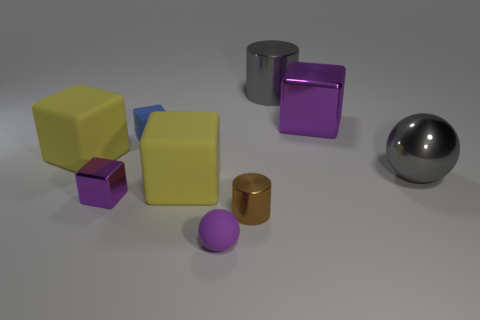The tiny cylinder that is on the right side of the small matte thing in front of the big thing that is on the left side of the small matte block is made of what material?
Offer a very short reply. Metal. Do the blue object and the large yellow cube to the right of the tiny blue matte object have the same material?
Provide a succinct answer. Yes. Are there fewer gray objects behind the blue matte thing than big yellow cubes to the left of the big gray sphere?
Keep it short and to the point. Yes. What number of blue cubes have the same material as the purple ball?
Offer a very short reply. 1. There is a large gray metallic thing that is right of the purple metal thing right of the tiny purple ball; is there a yellow cube in front of it?
Ensure brevity in your answer.  Yes. What number of cylinders are blue things or brown metal things?
Your answer should be compact. 1. There is a brown metallic thing; does it have the same shape as the gray shiny object that is behind the big gray metal ball?
Your answer should be very brief. Yes. Are there fewer gray cylinders that are in front of the small metallic cube than green metallic things?
Keep it short and to the point. No. There is a brown cylinder; are there any large cylinders to the left of it?
Your answer should be compact. No. Are there any big gray metal objects that have the same shape as the purple rubber thing?
Give a very brief answer. Yes. 